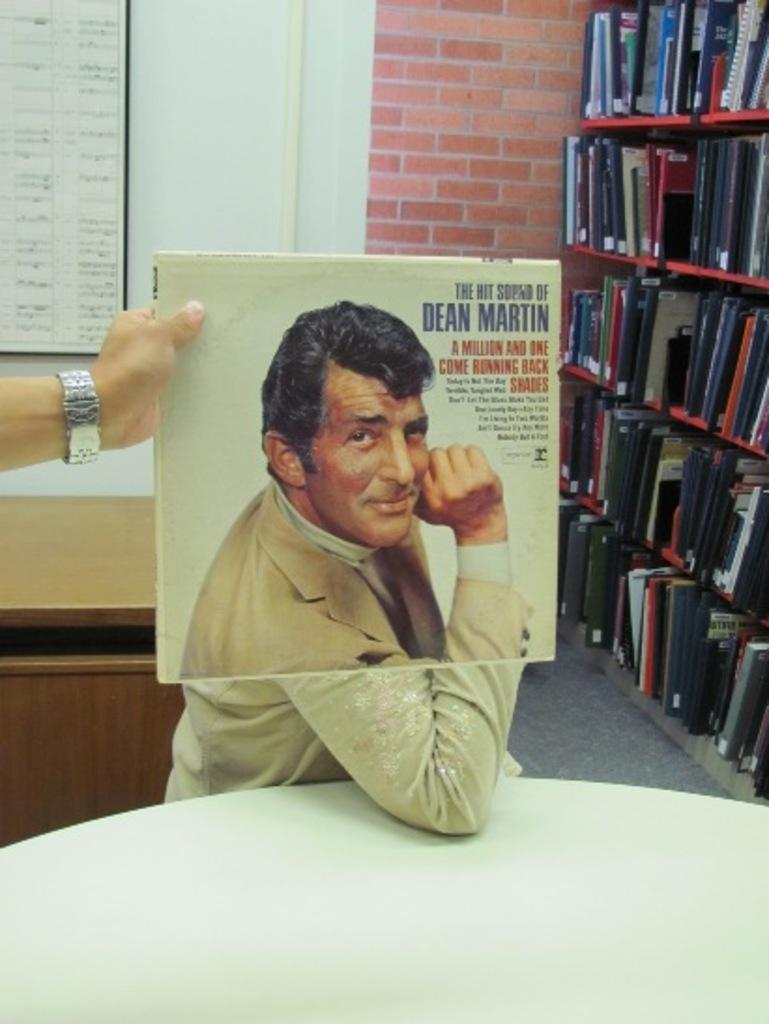Provide a one-sentence caption for the provided image. A music album of the hit sound of Dean Martin. 